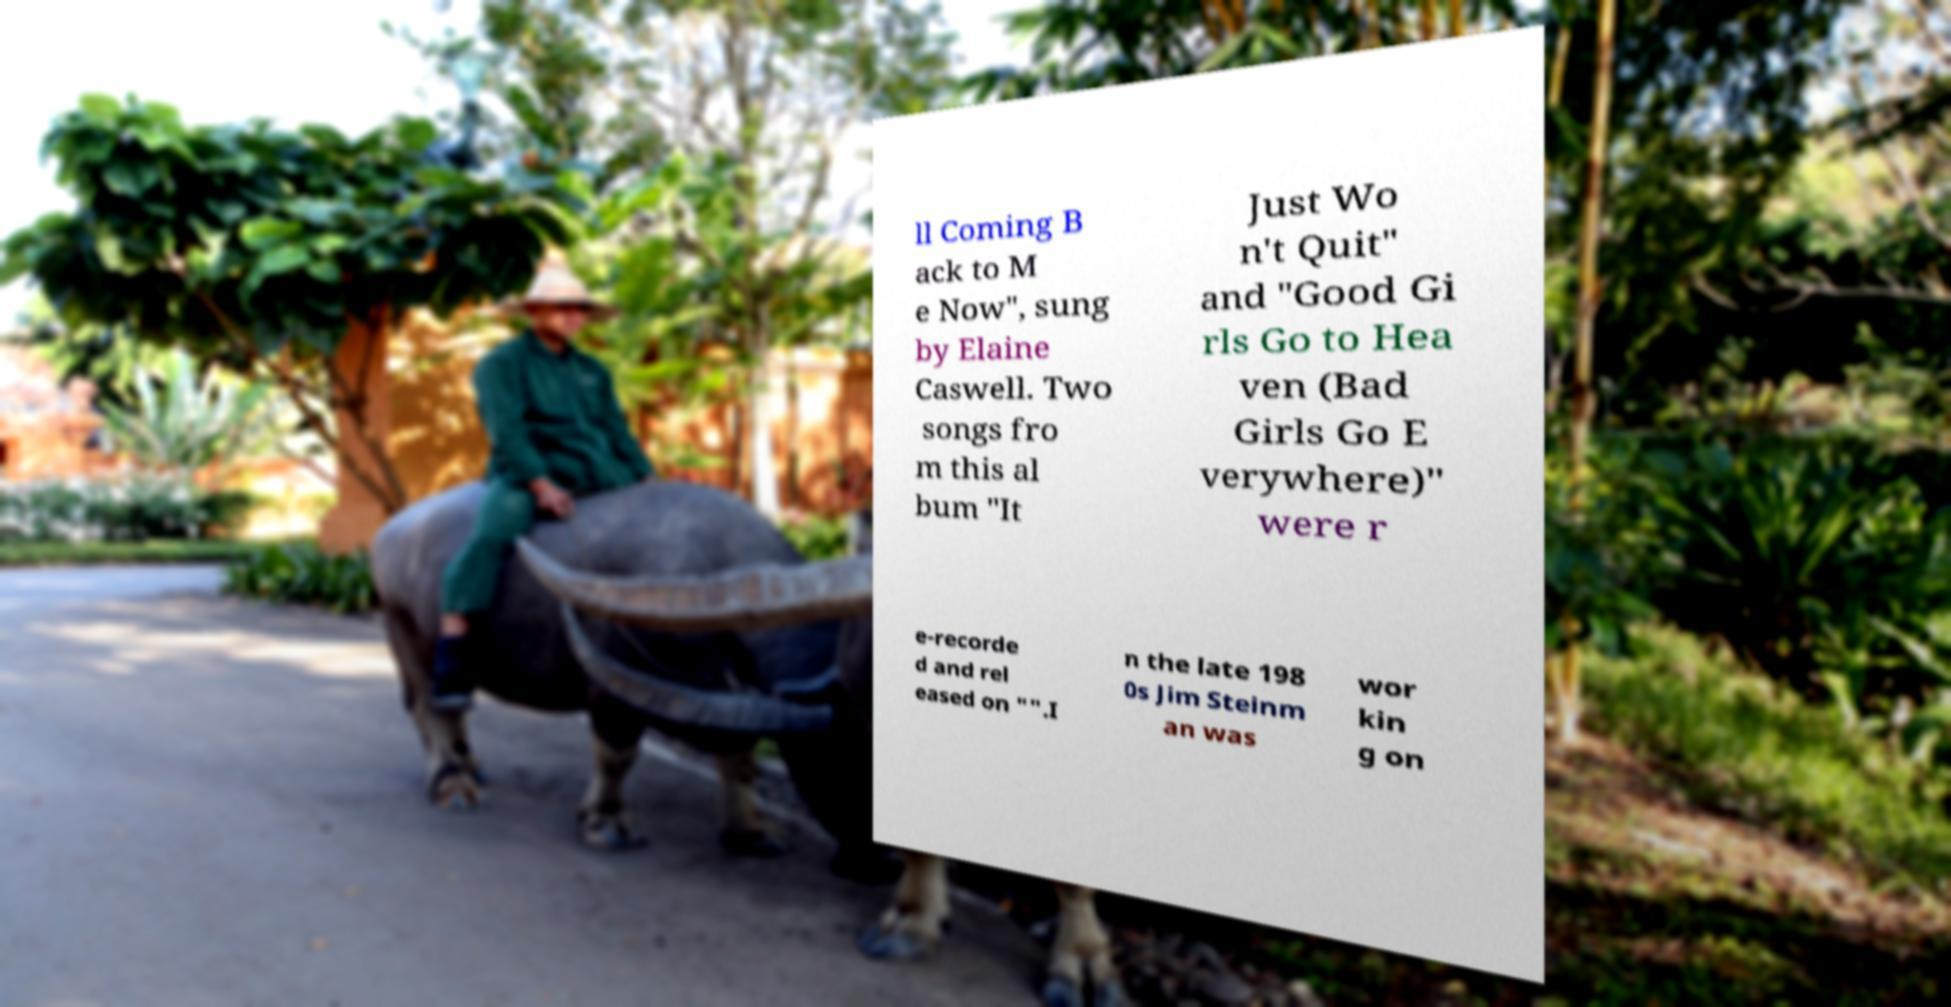Could you extract and type out the text from this image? ll Coming B ack to M e Now", sung by Elaine Caswell. Two songs fro m this al bum "It Just Wo n't Quit" and "Good Gi rls Go to Hea ven (Bad Girls Go E verywhere)" were r e-recorde d and rel eased on "".I n the late 198 0s Jim Steinm an was wor kin g on 